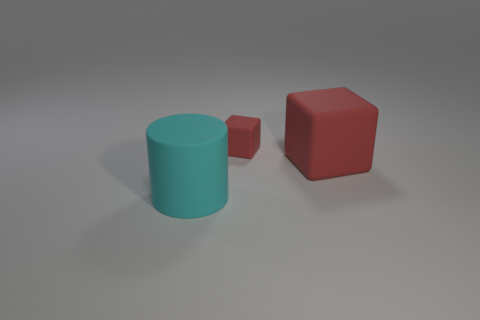Add 3 cylinders. How many objects exist? 6 Subtract 1 cylinders. How many cylinders are left? 0 Subtract all cylinders. How many objects are left? 2 Add 2 large rubber cylinders. How many large rubber cylinders exist? 3 Subtract 2 red blocks. How many objects are left? 1 Subtract all purple cubes. Subtract all brown spheres. How many cubes are left? 2 Subtract all small matte objects. Subtract all big green rubber cubes. How many objects are left? 2 Add 1 red objects. How many red objects are left? 3 